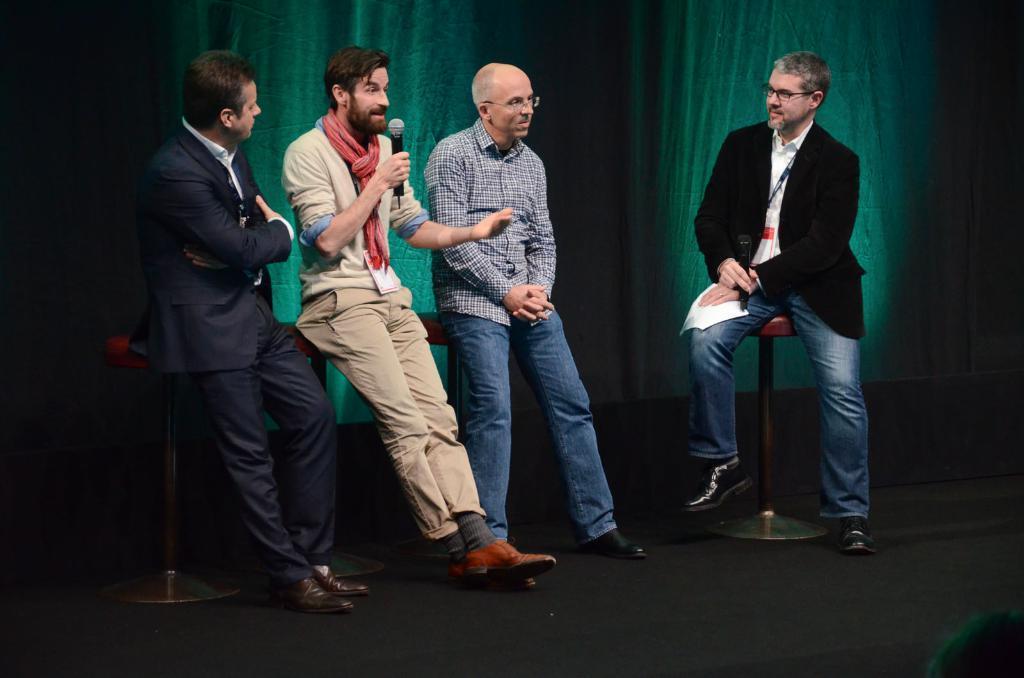Can you describe this image briefly? In the center of the image we can see a few people are sitting and they are in different costumes. Among them, we can see two persons are holding some objects. In the background there is a curtain. 